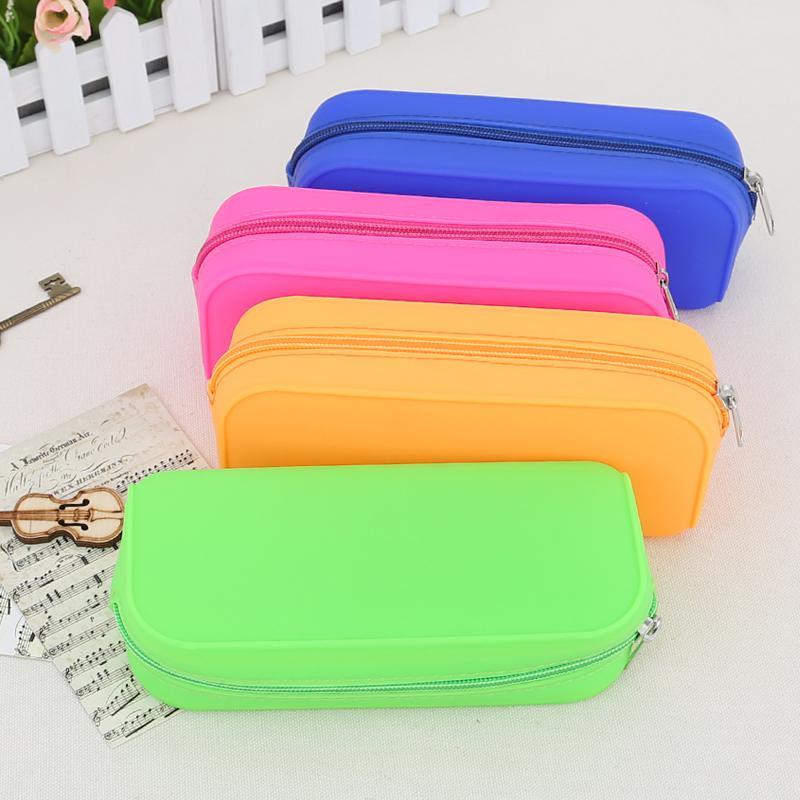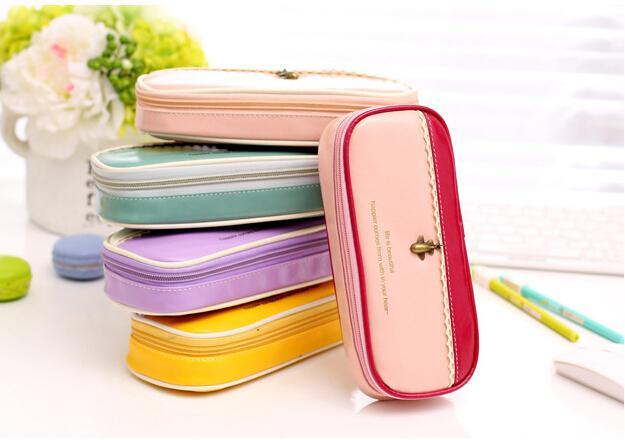The first image is the image on the left, the second image is the image on the right. For the images shown, is this caption "The right image contains four different colored small bags." true? Answer yes or no. No. The first image is the image on the left, the second image is the image on the right. For the images displayed, is the sentence "There are four cases in the image on the left." factually correct? Answer yes or no. Yes. 